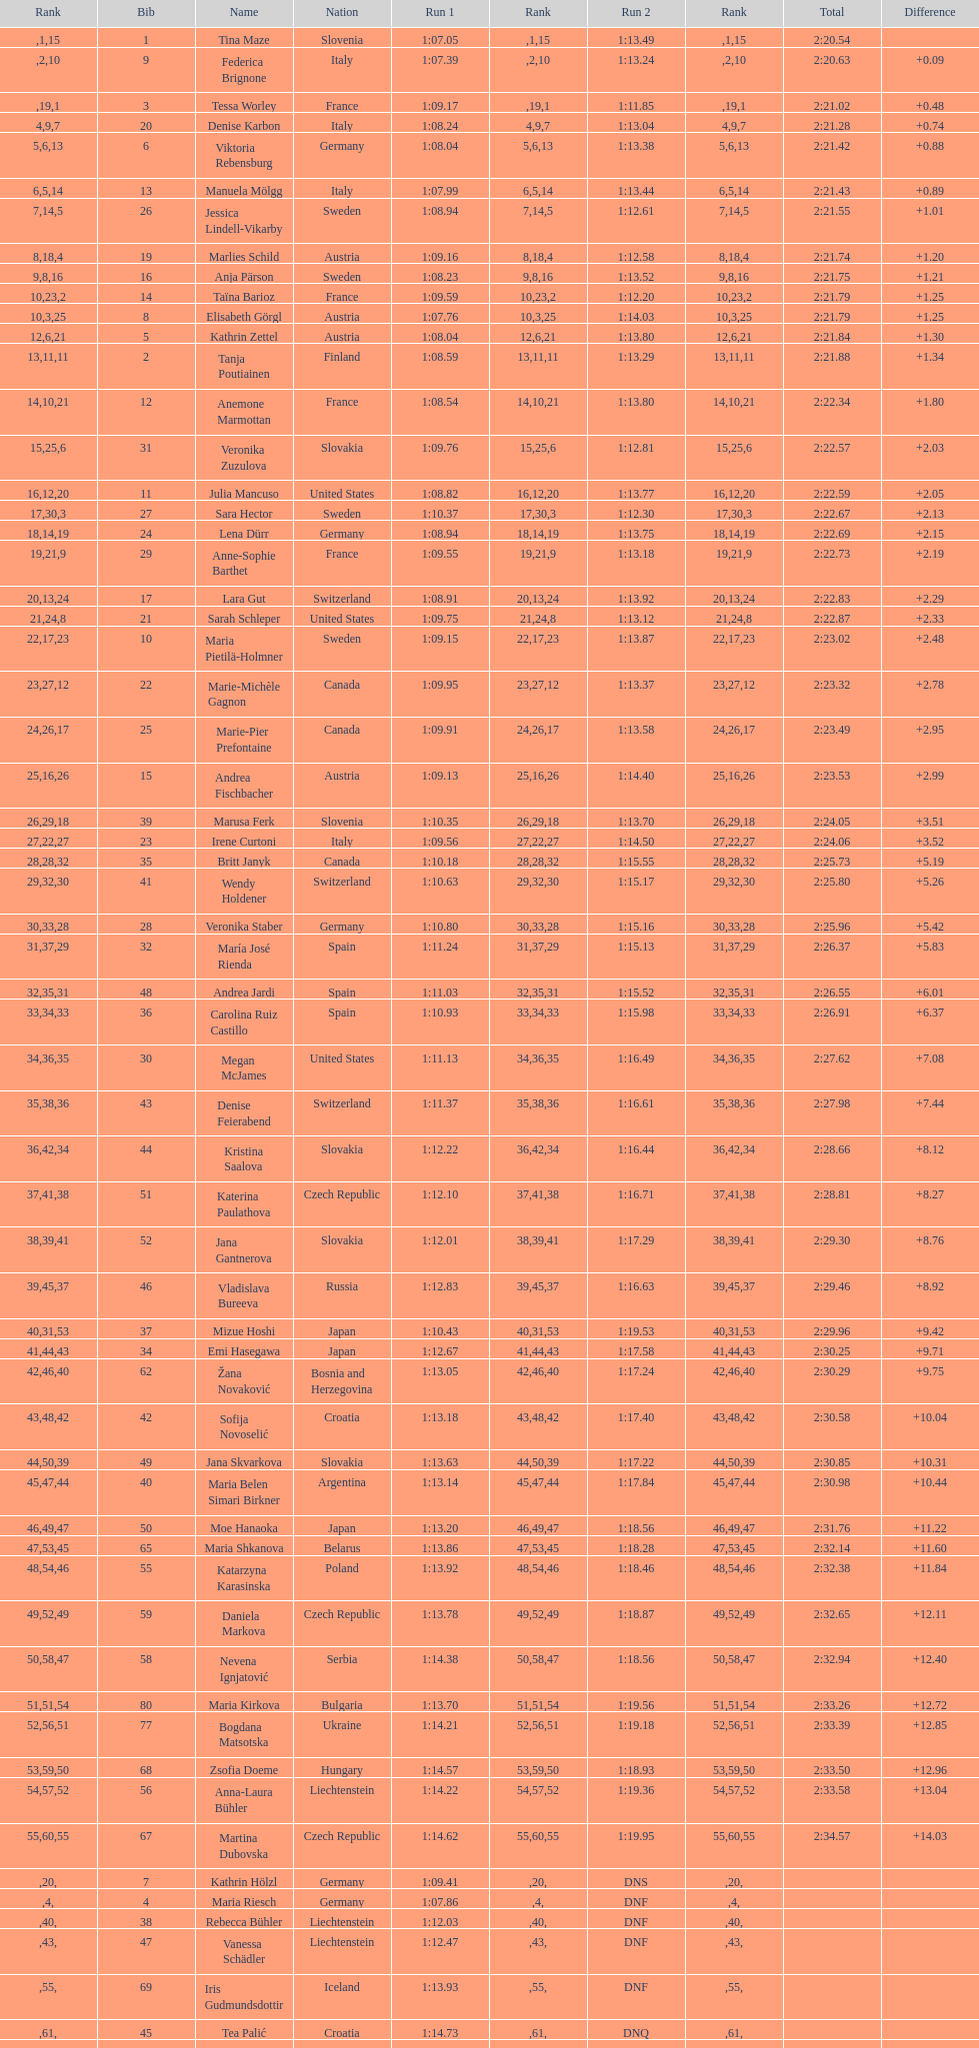Could you help me parse every detail presented in this table? {'header': ['Rank', 'Bib', 'Name', 'Nation', 'Run 1', 'Rank', 'Run 2', 'Rank', 'Total', 'Difference'], 'rows': [['', '1', 'Tina Maze', 'Slovenia', '1:07.05', '1', '1:13.49', '15', '2:20.54', ''], ['', '9', 'Federica Brignone', 'Italy', '1:07.39', '2', '1:13.24', '10', '2:20.63', '+0.09'], ['', '3', 'Tessa Worley', 'France', '1:09.17', '19', '1:11.85', '1', '2:21.02', '+0.48'], ['4', '20', 'Denise Karbon', 'Italy', '1:08.24', '9', '1:13.04', '7', '2:21.28', '+0.74'], ['5', '6', 'Viktoria Rebensburg', 'Germany', '1:08.04', '6', '1:13.38', '13', '2:21.42', '+0.88'], ['6', '13', 'Manuela Mölgg', 'Italy', '1:07.99', '5', '1:13.44', '14', '2:21.43', '+0.89'], ['7', '26', 'Jessica Lindell-Vikarby', 'Sweden', '1:08.94', '14', '1:12.61', '5', '2:21.55', '+1.01'], ['8', '19', 'Marlies Schild', 'Austria', '1:09.16', '18', '1:12.58', '4', '2:21.74', '+1.20'], ['9', '16', 'Anja Pärson', 'Sweden', '1:08.23', '8', '1:13.52', '16', '2:21.75', '+1.21'], ['10', '14', 'Taïna Barioz', 'France', '1:09.59', '23', '1:12.20', '2', '2:21.79', '+1.25'], ['10', '8', 'Elisabeth Görgl', 'Austria', '1:07.76', '3', '1:14.03', '25', '2:21.79', '+1.25'], ['12', '5', 'Kathrin Zettel', 'Austria', '1:08.04', '6', '1:13.80', '21', '2:21.84', '+1.30'], ['13', '2', 'Tanja Poutiainen', 'Finland', '1:08.59', '11', '1:13.29', '11', '2:21.88', '+1.34'], ['14', '12', 'Anemone Marmottan', 'France', '1:08.54', '10', '1:13.80', '21', '2:22.34', '+1.80'], ['15', '31', 'Veronika Zuzulova', 'Slovakia', '1:09.76', '25', '1:12.81', '6', '2:22.57', '+2.03'], ['16', '11', 'Julia Mancuso', 'United States', '1:08.82', '12', '1:13.77', '20', '2:22.59', '+2.05'], ['17', '27', 'Sara Hector', 'Sweden', '1:10.37', '30', '1:12.30', '3', '2:22.67', '+2.13'], ['18', '24', 'Lena Dürr', 'Germany', '1:08.94', '14', '1:13.75', '19', '2:22.69', '+2.15'], ['19', '29', 'Anne-Sophie Barthet', 'France', '1:09.55', '21', '1:13.18', '9', '2:22.73', '+2.19'], ['20', '17', 'Lara Gut', 'Switzerland', '1:08.91', '13', '1:13.92', '24', '2:22.83', '+2.29'], ['21', '21', 'Sarah Schleper', 'United States', '1:09.75', '24', '1:13.12', '8', '2:22.87', '+2.33'], ['22', '10', 'Maria Pietilä-Holmner', 'Sweden', '1:09.15', '17', '1:13.87', '23', '2:23.02', '+2.48'], ['23', '22', 'Marie-Michèle Gagnon', 'Canada', '1:09.95', '27', '1:13.37', '12', '2:23.32', '+2.78'], ['24', '25', 'Marie-Pier Prefontaine', 'Canada', '1:09.91', '26', '1:13.58', '17', '2:23.49', '+2.95'], ['25', '15', 'Andrea Fischbacher', 'Austria', '1:09.13', '16', '1:14.40', '26', '2:23.53', '+2.99'], ['26', '39', 'Marusa Ferk', 'Slovenia', '1:10.35', '29', '1:13.70', '18', '2:24.05', '+3.51'], ['27', '23', 'Irene Curtoni', 'Italy', '1:09.56', '22', '1:14.50', '27', '2:24.06', '+3.52'], ['28', '35', 'Britt Janyk', 'Canada', '1:10.18', '28', '1:15.55', '32', '2:25.73', '+5.19'], ['29', '41', 'Wendy Holdener', 'Switzerland', '1:10.63', '32', '1:15.17', '30', '2:25.80', '+5.26'], ['30', '28', 'Veronika Staber', 'Germany', '1:10.80', '33', '1:15.16', '28', '2:25.96', '+5.42'], ['31', '32', 'María José Rienda', 'Spain', '1:11.24', '37', '1:15.13', '29', '2:26.37', '+5.83'], ['32', '48', 'Andrea Jardi', 'Spain', '1:11.03', '35', '1:15.52', '31', '2:26.55', '+6.01'], ['33', '36', 'Carolina Ruiz Castillo', 'Spain', '1:10.93', '34', '1:15.98', '33', '2:26.91', '+6.37'], ['34', '30', 'Megan McJames', 'United States', '1:11.13', '36', '1:16.49', '35', '2:27.62', '+7.08'], ['35', '43', 'Denise Feierabend', 'Switzerland', '1:11.37', '38', '1:16.61', '36', '2:27.98', '+7.44'], ['36', '44', 'Kristina Saalova', 'Slovakia', '1:12.22', '42', '1:16.44', '34', '2:28.66', '+8.12'], ['37', '51', 'Katerina Paulathova', 'Czech Republic', '1:12.10', '41', '1:16.71', '38', '2:28.81', '+8.27'], ['38', '52', 'Jana Gantnerova', 'Slovakia', '1:12.01', '39', '1:17.29', '41', '2:29.30', '+8.76'], ['39', '46', 'Vladislava Bureeva', 'Russia', '1:12.83', '45', '1:16.63', '37', '2:29.46', '+8.92'], ['40', '37', 'Mizue Hoshi', 'Japan', '1:10.43', '31', '1:19.53', '53', '2:29.96', '+9.42'], ['41', '34', 'Emi Hasegawa', 'Japan', '1:12.67', '44', '1:17.58', '43', '2:30.25', '+9.71'], ['42', '62', 'Žana Novaković', 'Bosnia and Herzegovina', '1:13.05', '46', '1:17.24', '40', '2:30.29', '+9.75'], ['43', '42', 'Sofija Novoselić', 'Croatia', '1:13.18', '48', '1:17.40', '42', '2:30.58', '+10.04'], ['44', '49', 'Jana Skvarkova', 'Slovakia', '1:13.63', '50', '1:17.22', '39', '2:30.85', '+10.31'], ['45', '40', 'Maria Belen Simari Birkner', 'Argentina', '1:13.14', '47', '1:17.84', '44', '2:30.98', '+10.44'], ['46', '50', 'Moe Hanaoka', 'Japan', '1:13.20', '49', '1:18.56', '47', '2:31.76', '+11.22'], ['47', '65', 'Maria Shkanova', 'Belarus', '1:13.86', '53', '1:18.28', '45', '2:32.14', '+11.60'], ['48', '55', 'Katarzyna Karasinska', 'Poland', '1:13.92', '54', '1:18.46', '46', '2:32.38', '+11.84'], ['49', '59', 'Daniela Markova', 'Czech Republic', '1:13.78', '52', '1:18.87', '49', '2:32.65', '+12.11'], ['50', '58', 'Nevena Ignjatović', 'Serbia', '1:14.38', '58', '1:18.56', '47', '2:32.94', '+12.40'], ['51', '80', 'Maria Kirkova', 'Bulgaria', '1:13.70', '51', '1:19.56', '54', '2:33.26', '+12.72'], ['52', '77', 'Bogdana Matsotska', 'Ukraine', '1:14.21', '56', '1:19.18', '51', '2:33.39', '+12.85'], ['53', '68', 'Zsofia Doeme', 'Hungary', '1:14.57', '59', '1:18.93', '50', '2:33.50', '+12.96'], ['54', '56', 'Anna-Laura Bühler', 'Liechtenstein', '1:14.22', '57', '1:19.36', '52', '2:33.58', '+13.04'], ['55', '67', 'Martina Dubovska', 'Czech Republic', '1:14.62', '60', '1:19.95', '55', '2:34.57', '+14.03'], ['', '7', 'Kathrin Hölzl', 'Germany', '1:09.41', '20', 'DNS', '', '', ''], ['', '4', 'Maria Riesch', 'Germany', '1:07.86', '4', 'DNF', '', '', ''], ['', '38', 'Rebecca Bühler', 'Liechtenstein', '1:12.03', '40', 'DNF', '', '', ''], ['', '47', 'Vanessa Schädler', 'Liechtenstein', '1:12.47', '43', 'DNF', '', '', ''], ['', '69', 'Iris Gudmundsdottir', 'Iceland', '1:13.93', '55', 'DNF', '', '', ''], ['', '45', 'Tea Palić', 'Croatia', '1:14.73', '61', 'DNQ', '', '', ''], ['', '74', 'Macarena Simari Birkner', 'Argentina', '1:15.18', '62', 'DNQ', '', '', ''], ['', '72', 'Lavinia Chrystal', 'Australia', '1:15.35', '63', 'DNQ', '', '', ''], ['', '81', 'Lelde Gasuna', 'Latvia', '1:15.37', '64', 'DNQ', '', '', ''], ['', '64', 'Aleksandra Klus', 'Poland', '1:15.41', '65', 'DNQ', '', '', ''], ['', '78', 'Nino Tsiklauri', 'Georgia', '1:15.54', '66', 'DNQ', '', '', ''], ['', '66', 'Sarah Jarvis', 'New Zealand', '1:15.94', '67', 'DNQ', '', '', ''], ['', '61', 'Anna Berecz', 'Hungary', '1:15.95', '68', 'DNQ', '', '', ''], ['', '83', 'Sandra-Elena Narea', 'Romania', '1:16.67', '69', 'DNQ', '', '', ''], ['', '85', 'Iulia Petruta Craciun', 'Romania', '1:16.80', '70', 'DNQ', '', '', ''], ['', '82', 'Isabel van Buynder', 'Belgium', '1:17.06', '71', 'DNQ', '', '', ''], ['', '97', 'Liene Fimbauere', 'Latvia', '1:17.83', '72', 'DNQ', '', '', ''], ['', '86', 'Kristina Krone', 'Puerto Rico', '1:17.93', '73', 'DNQ', '', '', ''], ['', '88', 'Nicole Valcareggi', 'Greece', '1:18.19', '74', 'DNQ', '', '', ''], ['', '100', 'Sophie Fjellvang-Sølling', 'Denmark', '1:18.37', '75', 'DNQ', '', '', ''], ['', '95', 'Ornella Oettl Reyes', 'Peru', '1:18.61', '76', 'DNQ', '', '', ''], ['', '73', 'Xia Lina', 'China', '1:19.12', '77', 'DNQ', '', '', ''], ['', '94', 'Kseniya Grigoreva', 'Uzbekistan', '1:19.16', '78', 'DNQ', '', '', ''], ['', '87', 'Tugba Dasdemir', 'Turkey', '1:21.50', '79', 'DNQ', '', '', ''], ['', '92', 'Malene Madsen', 'Denmark', '1:22.25', '80', 'DNQ', '', '', ''], ['', '84', 'Liu Yang', 'China', '1:22.80', '81', 'DNQ', '', '', ''], ['', '91', 'Yom Hirshfeld', 'Israel', '1:22.87', '82', 'DNQ', '', '', ''], ['', '75', 'Salome Bancora', 'Argentina', '1:23.08', '83', 'DNQ', '', '', ''], ['', '93', 'Ronnie Kiek-Gedalyahu', 'Israel', '1:23.38', '84', 'DNQ', '', '', ''], ['', '96', 'Chiara Marano', 'Brazil', '1:24.16', '85', 'DNQ', '', '', ''], ['', '113', 'Anne Libak Nielsen', 'Denmark', '1:25.08', '86', 'DNQ', '', '', ''], ['', '105', 'Donata Hellner', 'Hungary', '1:26.97', '87', 'DNQ', '', '', ''], ['', '102', 'Liu Yu', 'China', '1:27.03', '88', 'DNQ', '', '', ''], ['', '109', 'Lida Zvoznikova', 'Kyrgyzstan', '1:27.17', '89', 'DNQ', '', '', ''], ['', '103', 'Szelina Hellner', 'Hungary', '1:27.27', '90', 'DNQ', '', '', ''], ['', '114', 'Irina Volkova', 'Kyrgyzstan', '1:29.73', '91', 'DNQ', '', '', ''], ['', '106', 'Svetlana Baranova', 'Uzbekistan', '1:30.62', '92', 'DNQ', '', '', ''], ['', '108', 'Tatjana Baranova', 'Uzbekistan', '1:31.81', '93', 'DNQ', '', '', ''], ['', '110', 'Fatemeh Kiadarbandsari', 'Iran', '1:32.16', '94', 'DNQ', '', '', ''], ['', '107', 'Ziba Kalhor', 'Iran', '1:32.64', '95', 'DNQ', '', '', ''], ['', '104', 'Paraskevi Mavridou', 'Greece', '1:32.83', '96', 'DNQ', '', '', ''], ['', '99', 'Marjan Kalhor', 'Iran', '1:34.94', '97', 'DNQ', '', '', ''], ['', '112', 'Mitra Kalhor', 'Iran', '1:37.93', '98', 'DNQ', '', '', ''], ['', '115', 'Laura Bauer', 'South Africa', '1:42.19', '99', 'DNQ', '', '', ''], ['', '111', 'Sarah Ekmekejian', 'Lebanon', '1:42.22', '100', 'DNQ', '', '', ''], ['', '18', 'Fabienne Suter', 'Switzerland', 'DNS', '', '', '', '', ''], ['', '98', 'Maja Klepić', 'Bosnia and Herzegovina', 'DNS', '', '', '', '', ''], ['', '33', 'Agniezska Gasienica Daniel', 'Poland', 'DNF', '', '', '', '', ''], ['', '53', 'Karolina Chrapek', 'Poland', 'DNF', '', '', '', '', ''], ['', '54', 'Mireia Gutierrez', 'Andorra', 'DNF', '', '', '', '', ''], ['', '57', 'Brittany Phelan', 'Canada', 'DNF', '', '', '', '', ''], ['', '60', 'Tereza Kmochova', 'Czech Republic', 'DNF', '', '', '', '', ''], ['', '63', 'Michelle van Herwerden', 'Netherlands', 'DNF', '', '', '', '', ''], ['', '70', 'Maya Harrisson', 'Brazil', 'DNF', '', '', '', '', ''], ['', '71', 'Elizabeth Pilat', 'Australia', 'DNF', '', '', '', '', ''], ['', '76', 'Katrin Kristjansdottir', 'Iceland', 'DNF', '', '', '', '', ''], ['', '79', 'Julietta Quiroga', 'Argentina', 'DNF', '', '', '', '', ''], ['', '89', 'Evija Benhena', 'Latvia', 'DNF', '', '', '', '', ''], ['', '90', 'Qin Xiyue', 'China', 'DNF', '', '', '', '', ''], ['', '101', 'Sophia Ralli', 'Greece', 'DNF', '', '', '', '', ''], ['', '116', 'Siranush Maghakyan', 'Armenia', 'DNF', '', '', '', '', '']]} How long did it take tina maze to finish the race? 2:20.54. 